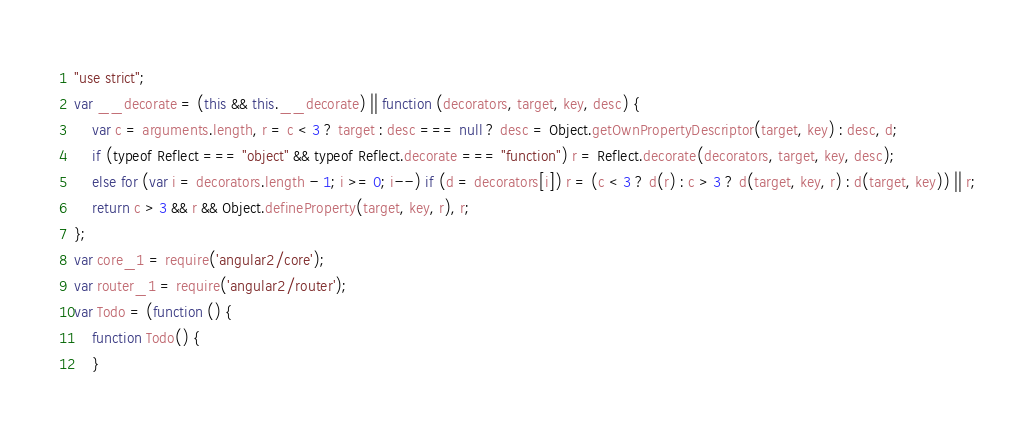<code> <loc_0><loc_0><loc_500><loc_500><_JavaScript_>"use strict";
var __decorate = (this && this.__decorate) || function (decorators, target, key, desc) {
    var c = arguments.length, r = c < 3 ? target : desc === null ? desc = Object.getOwnPropertyDescriptor(target, key) : desc, d;
    if (typeof Reflect === "object" && typeof Reflect.decorate === "function") r = Reflect.decorate(decorators, target, key, desc);
    else for (var i = decorators.length - 1; i >= 0; i--) if (d = decorators[i]) r = (c < 3 ? d(r) : c > 3 ? d(target, key, r) : d(target, key)) || r;
    return c > 3 && r && Object.defineProperty(target, key, r), r;
};
var core_1 = require('angular2/core');
var router_1 = require('angular2/router');
var Todo = (function () {
    function Todo() {
    }</code> 